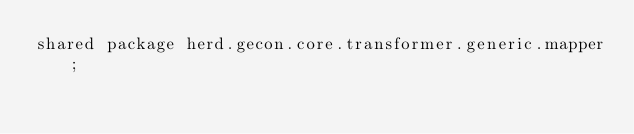Convert code to text. <code><loc_0><loc_0><loc_500><loc_500><_Ceylon_>shared package herd.gecon.core.transformer.generic.mapper;
</code> 